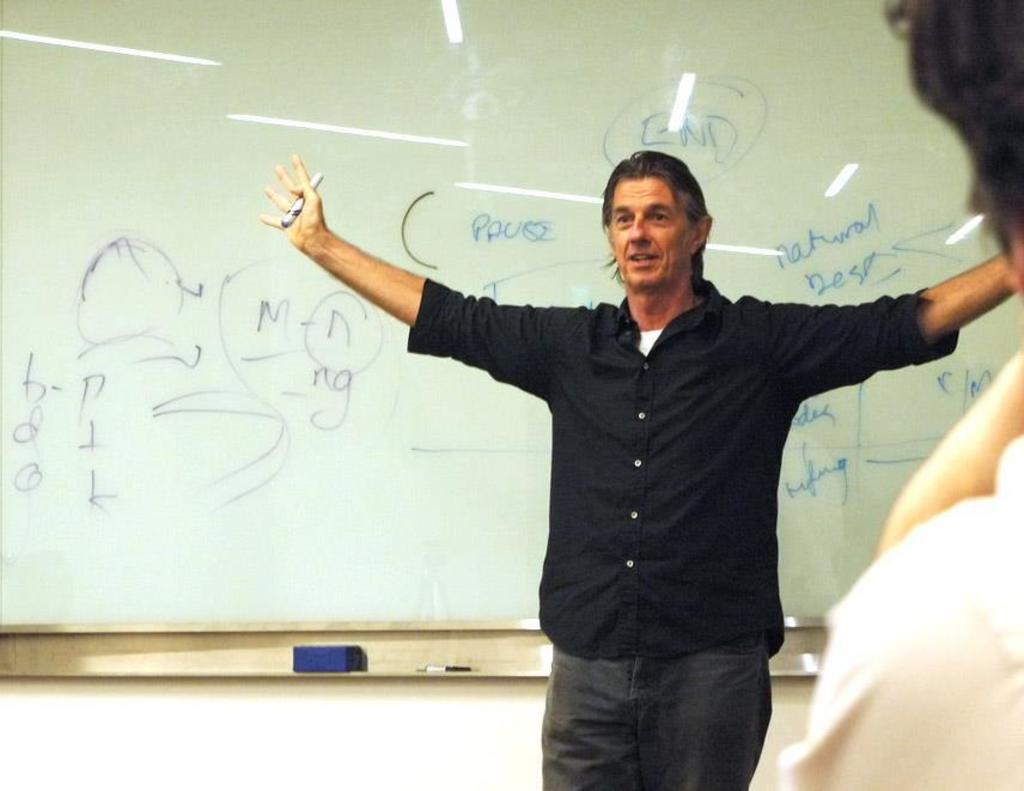<image>
Offer a succinct explanation of the picture presented. And man is standing in front of a white board with the word "END" written above his head. 